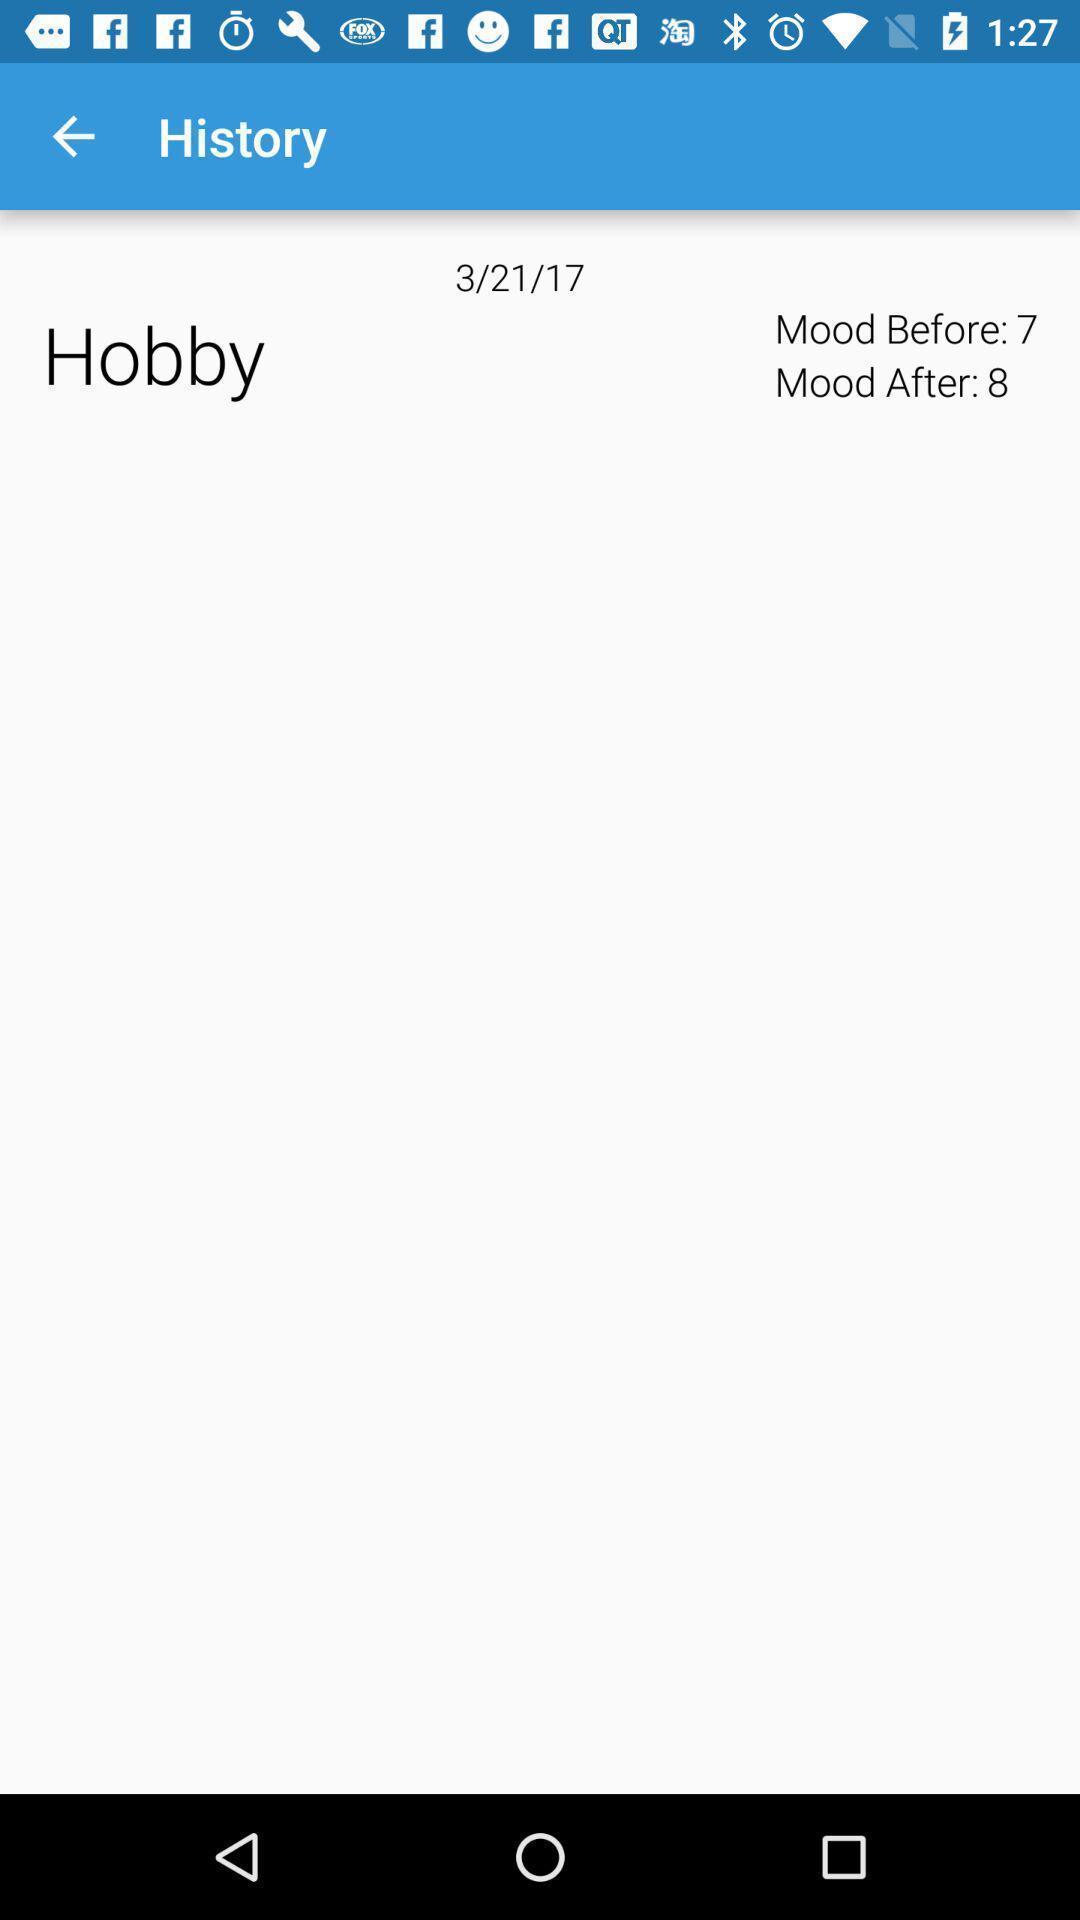What details can you identify in this image? Page shows the history of mood swings time and date. 